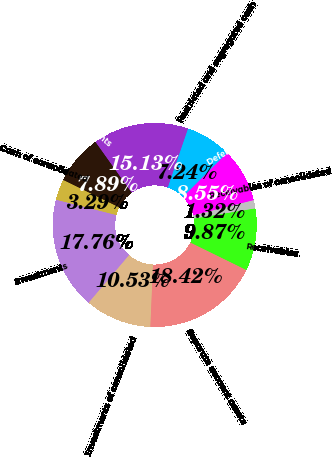Convert chart to OTSL. <chart><loc_0><loc_0><loc_500><loc_500><pie_chart><fcel>Cash and cash equivalents<fcel>Cash of consolidated<fcel>Investments<fcel>Investments of consolidated<fcel>Separate account assets<fcel>Receivables<fcel>Receivables of consolidated<fcel>Deferred acquisition costs<fcel>Restricted and segregated cash<fcel>Other assets<nl><fcel>7.89%<fcel>3.29%<fcel>17.76%<fcel>10.53%<fcel>18.42%<fcel>9.87%<fcel>1.32%<fcel>8.55%<fcel>7.24%<fcel>15.13%<nl></chart> 